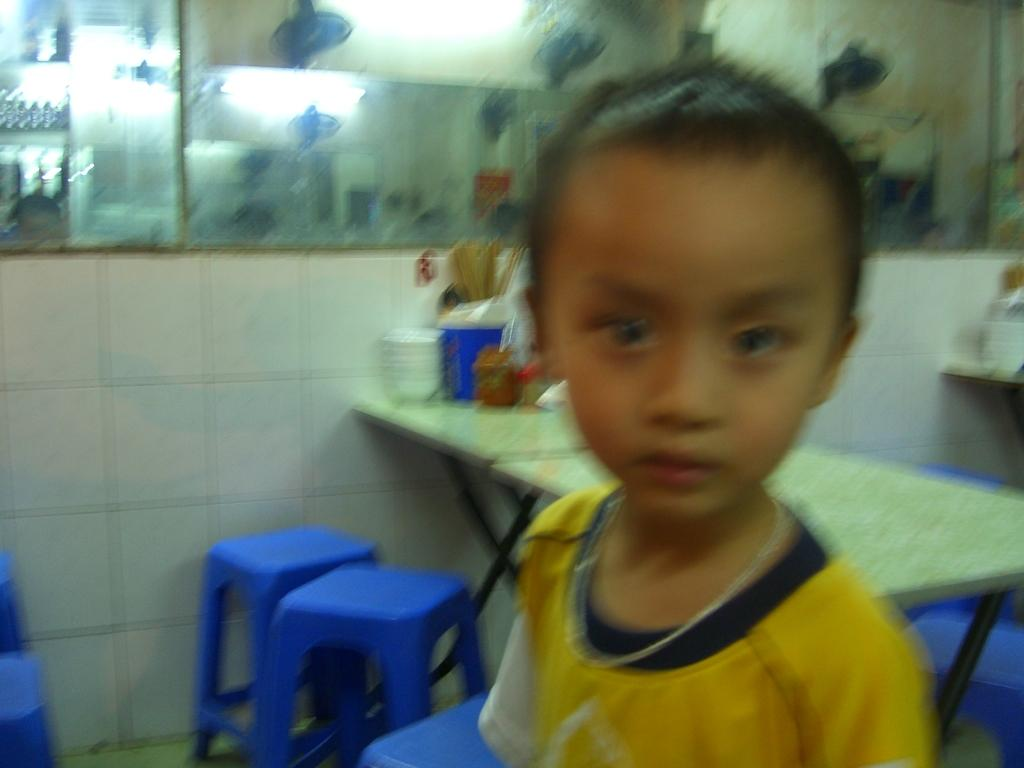Who is the main subject in the image? There is a boy in the image. What is the boy wearing? The boy is wearing a yellow dress. What can be seen in the background of the image? There is a table and a stool in the background of the image. What is the purpose of the circle in the image? There is no circle present in the image. 